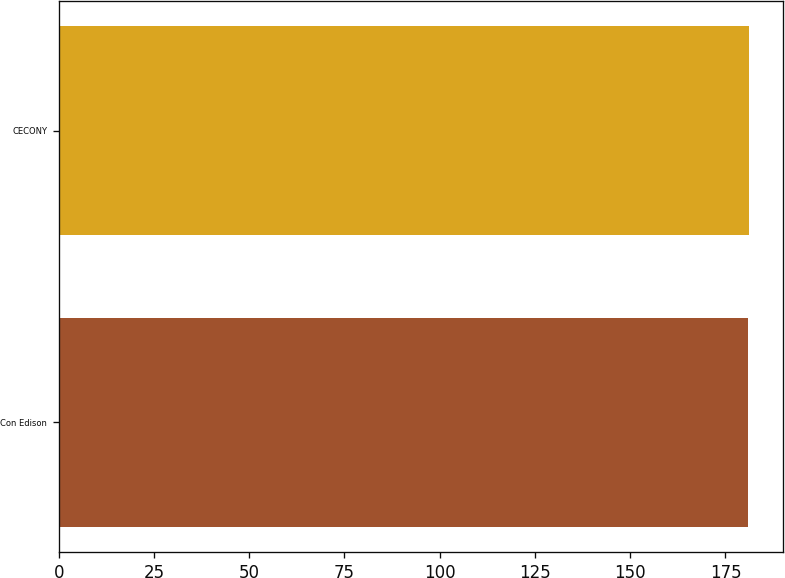<chart> <loc_0><loc_0><loc_500><loc_500><bar_chart><fcel>Con Edison<fcel>CECONY<nl><fcel>181<fcel>181.1<nl></chart> 